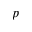Convert formula to latex. <formula><loc_0><loc_0><loc_500><loc_500>p</formula> 